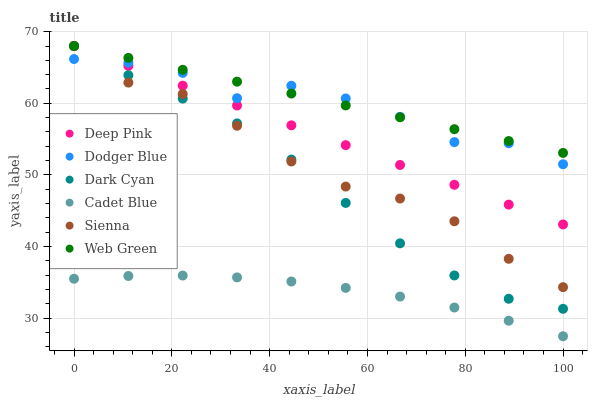Does Cadet Blue have the minimum area under the curve?
Answer yes or no. Yes. Does Web Green have the maximum area under the curve?
Answer yes or no. Yes. Does Sienna have the minimum area under the curve?
Answer yes or no. No. Does Sienna have the maximum area under the curve?
Answer yes or no. No. Is Deep Pink the smoothest?
Answer yes or no. Yes. Is Dodger Blue the roughest?
Answer yes or no. Yes. Is Web Green the smoothest?
Answer yes or no. No. Is Web Green the roughest?
Answer yes or no. No. Does Cadet Blue have the lowest value?
Answer yes or no. Yes. Does Sienna have the lowest value?
Answer yes or no. No. Does Dark Cyan have the highest value?
Answer yes or no. Yes. Does Cadet Blue have the highest value?
Answer yes or no. No. Is Cadet Blue less than Dark Cyan?
Answer yes or no. Yes. Is Dark Cyan greater than Cadet Blue?
Answer yes or no. Yes. Does Dark Cyan intersect Sienna?
Answer yes or no. Yes. Is Dark Cyan less than Sienna?
Answer yes or no. No. Is Dark Cyan greater than Sienna?
Answer yes or no. No. Does Cadet Blue intersect Dark Cyan?
Answer yes or no. No. 